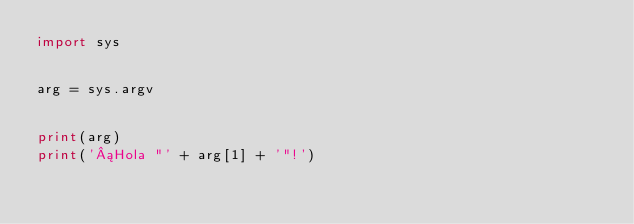Convert code to text. <code><loc_0><loc_0><loc_500><loc_500><_Python_>import sys


arg = sys.argv


print(arg)
print('¡Hola "' + arg[1] + '"!')

</code> 